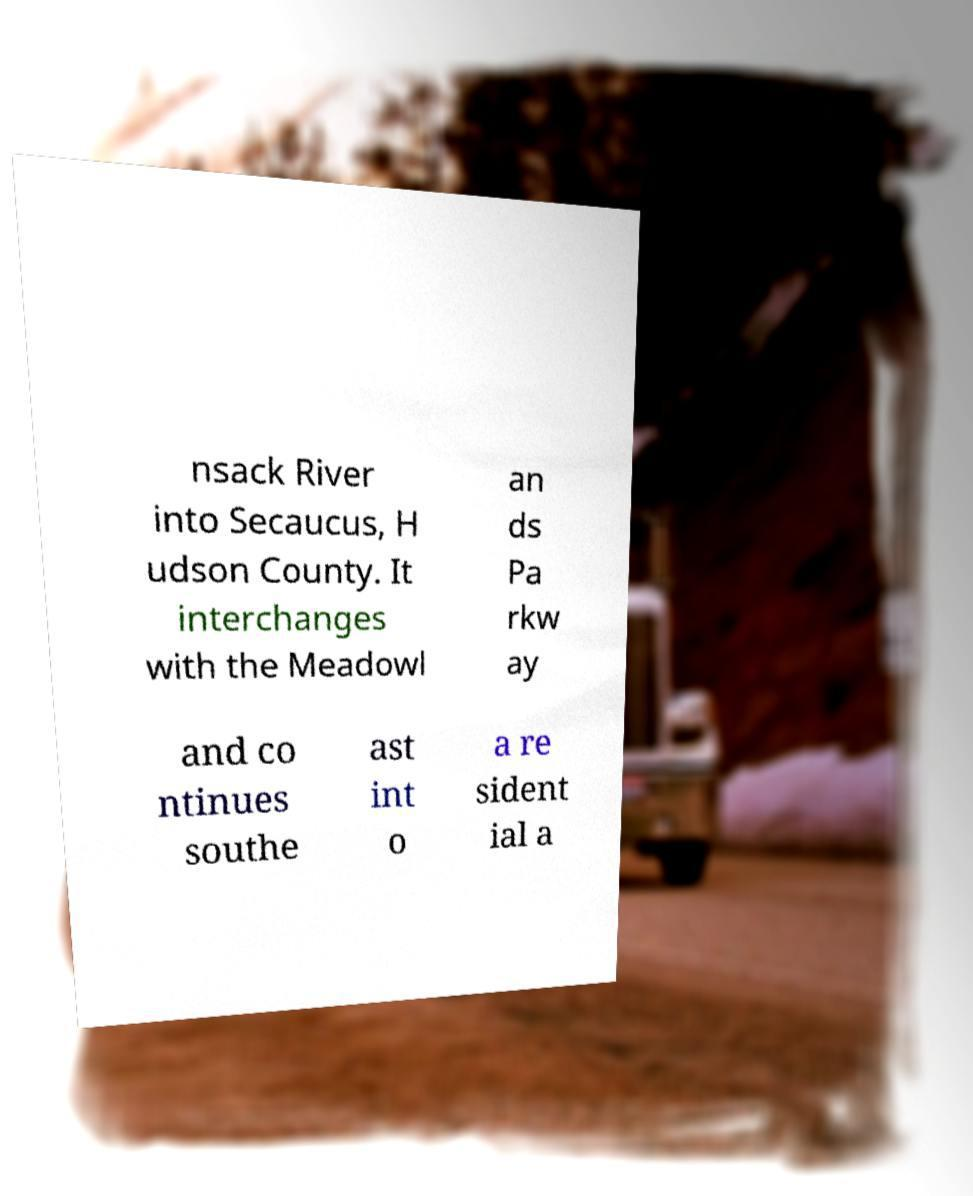Could you extract and type out the text from this image? nsack River into Secaucus, H udson County. It interchanges with the Meadowl an ds Pa rkw ay and co ntinues southe ast int o a re sident ial a 